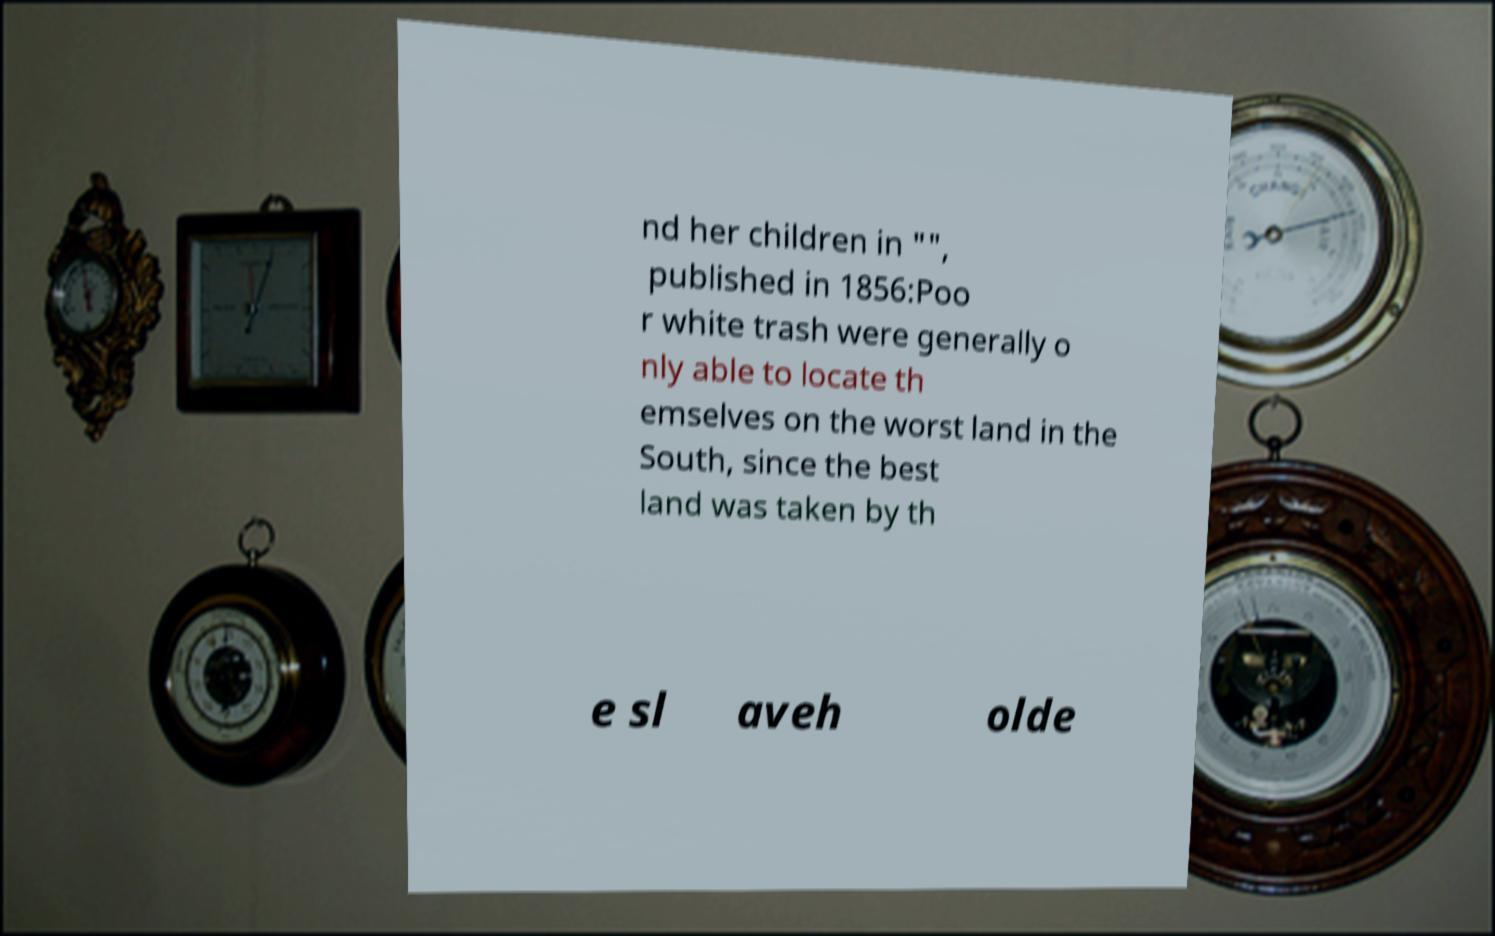I need the written content from this picture converted into text. Can you do that? nd her children in "", published in 1856:Poo r white trash were generally o nly able to locate th emselves on the worst land in the South, since the best land was taken by th e sl aveh olde 